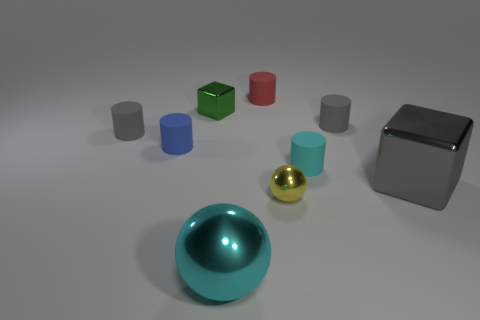Subtract all small cyan rubber cylinders. How many cylinders are left? 4 Subtract all blue blocks. How many gray cylinders are left? 2 Add 1 cubes. How many objects exist? 10 Subtract 3 cylinders. How many cylinders are left? 2 Subtract all cyan cylinders. How many cylinders are left? 4 Subtract all blocks. How many objects are left? 7 Subtract all large rubber objects. Subtract all shiny blocks. How many objects are left? 7 Add 5 gray cubes. How many gray cubes are left? 6 Add 7 big yellow metallic cubes. How many big yellow metallic cubes exist? 7 Subtract 1 gray cubes. How many objects are left? 8 